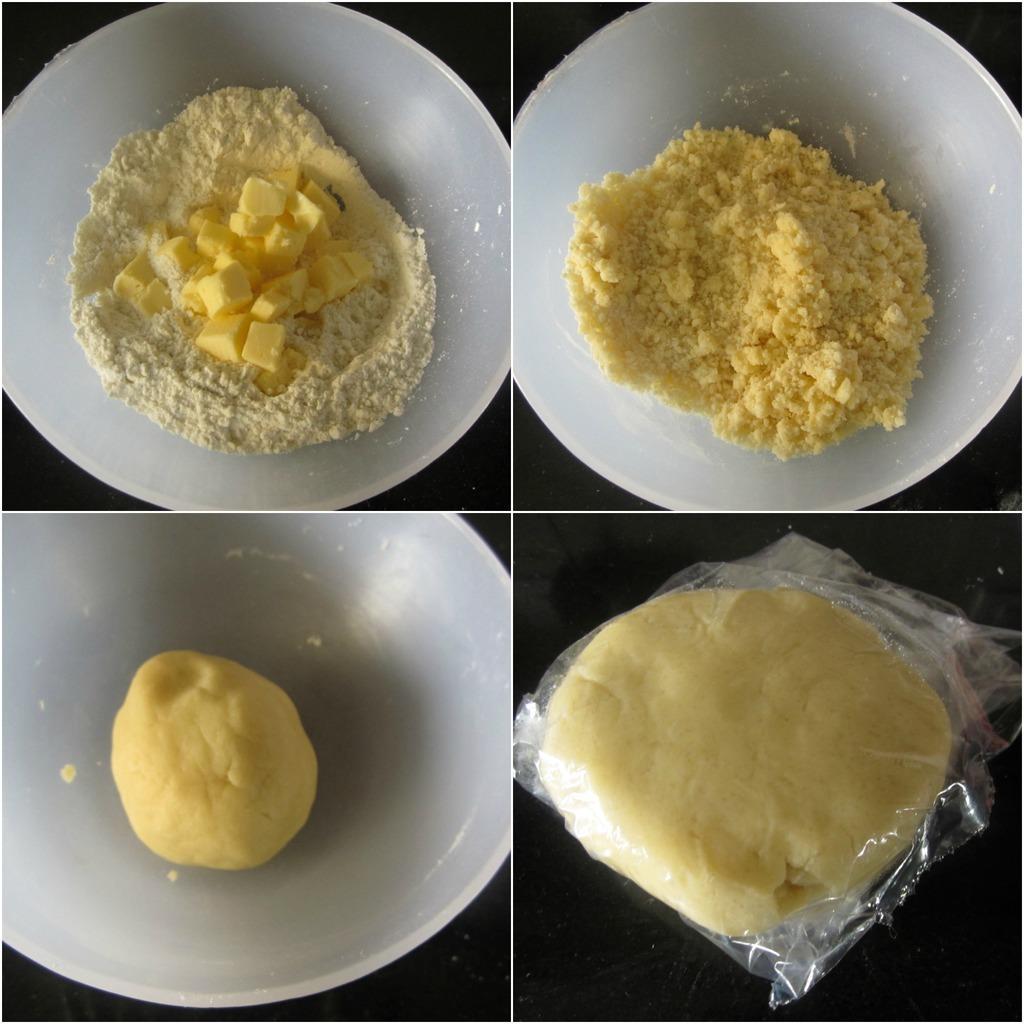Could you give a brief overview of what you see in this image? In this image I can see the collage picture in which I can see a white colored bowl, the cream colored flour in the bowl, the butter in the bowl and a flour dough in the bowl. I can see the black colored surface and on it I can see a plastic cover with flour dough in it. 